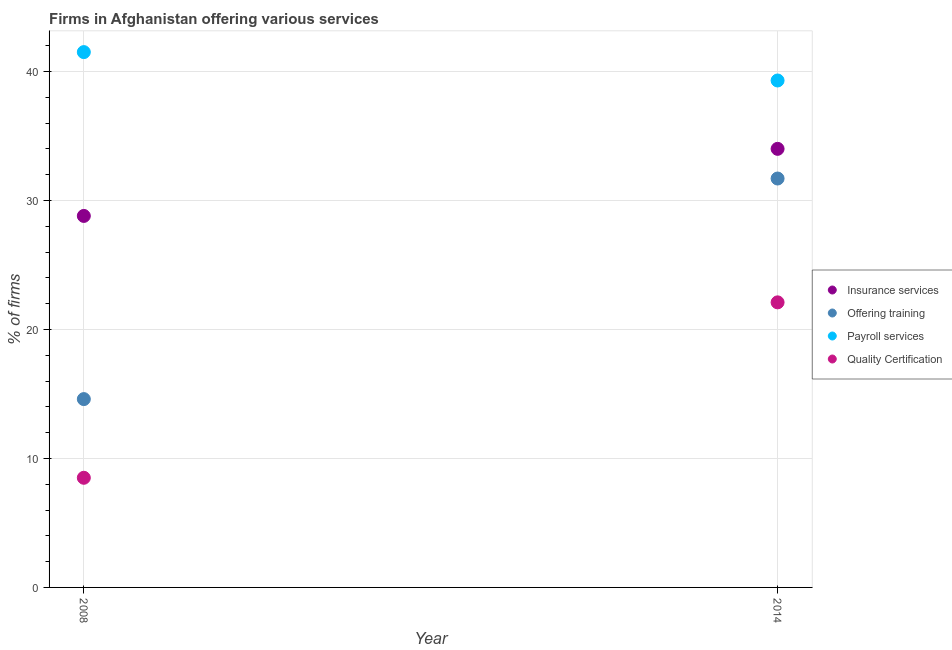How many different coloured dotlines are there?
Your response must be concise. 4. Is the number of dotlines equal to the number of legend labels?
Make the answer very short. Yes. What is the percentage of firms offering payroll services in 2014?
Keep it short and to the point. 39.3. Across all years, what is the minimum percentage of firms offering training?
Provide a succinct answer. 14.6. What is the total percentage of firms offering training in the graph?
Make the answer very short. 46.3. What is the difference between the percentage of firms offering insurance services in 2008 and that in 2014?
Provide a short and direct response. -5.2. What is the difference between the percentage of firms offering training in 2014 and the percentage of firms offering quality certification in 2008?
Provide a succinct answer. 23.2. What is the average percentage of firms offering payroll services per year?
Ensure brevity in your answer.  40.4. In the year 2014, what is the difference between the percentage of firms offering insurance services and percentage of firms offering training?
Your answer should be very brief. 2.3. In how many years, is the percentage of firms offering training greater than 38 %?
Keep it short and to the point. 0. What is the ratio of the percentage of firms offering insurance services in 2008 to that in 2014?
Ensure brevity in your answer.  0.85. Is the percentage of firms offering insurance services in 2008 less than that in 2014?
Keep it short and to the point. Yes. In how many years, is the percentage of firms offering payroll services greater than the average percentage of firms offering payroll services taken over all years?
Offer a very short reply. 1. Is it the case that in every year, the sum of the percentage of firms offering payroll services and percentage of firms offering insurance services is greater than the sum of percentage of firms offering quality certification and percentage of firms offering training?
Offer a terse response. Yes. Is it the case that in every year, the sum of the percentage of firms offering insurance services and percentage of firms offering training is greater than the percentage of firms offering payroll services?
Provide a short and direct response. Yes. Is the percentage of firms offering quality certification strictly greater than the percentage of firms offering payroll services over the years?
Provide a short and direct response. No. How many dotlines are there?
Your answer should be compact. 4. How many years are there in the graph?
Your answer should be compact. 2. What is the difference between two consecutive major ticks on the Y-axis?
Ensure brevity in your answer.  10. Does the graph contain any zero values?
Ensure brevity in your answer.  No. Does the graph contain grids?
Ensure brevity in your answer.  Yes. Where does the legend appear in the graph?
Offer a very short reply. Center right. How many legend labels are there?
Offer a terse response. 4. What is the title of the graph?
Give a very brief answer. Firms in Afghanistan offering various services . What is the label or title of the Y-axis?
Give a very brief answer. % of firms. What is the % of firms of Insurance services in 2008?
Keep it short and to the point. 28.8. What is the % of firms of Payroll services in 2008?
Your response must be concise. 41.5. What is the % of firms of Insurance services in 2014?
Keep it short and to the point. 34. What is the % of firms in Offering training in 2014?
Give a very brief answer. 31.7. What is the % of firms of Payroll services in 2014?
Your answer should be compact. 39.3. What is the % of firms of Quality Certification in 2014?
Give a very brief answer. 22.1. Across all years, what is the maximum % of firms of Offering training?
Give a very brief answer. 31.7. Across all years, what is the maximum % of firms of Payroll services?
Your response must be concise. 41.5. Across all years, what is the maximum % of firms of Quality Certification?
Offer a very short reply. 22.1. Across all years, what is the minimum % of firms of Insurance services?
Provide a short and direct response. 28.8. Across all years, what is the minimum % of firms in Offering training?
Your answer should be compact. 14.6. Across all years, what is the minimum % of firms in Payroll services?
Your answer should be compact. 39.3. What is the total % of firms in Insurance services in the graph?
Offer a terse response. 62.8. What is the total % of firms of Offering training in the graph?
Provide a short and direct response. 46.3. What is the total % of firms in Payroll services in the graph?
Your answer should be compact. 80.8. What is the total % of firms in Quality Certification in the graph?
Keep it short and to the point. 30.6. What is the difference between the % of firms of Insurance services in 2008 and that in 2014?
Your answer should be very brief. -5.2. What is the difference between the % of firms in Offering training in 2008 and that in 2014?
Your answer should be compact. -17.1. What is the difference between the % of firms of Insurance services in 2008 and the % of firms of Offering training in 2014?
Give a very brief answer. -2.9. What is the difference between the % of firms in Insurance services in 2008 and the % of firms in Payroll services in 2014?
Give a very brief answer. -10.5. What is the difference between the % of firms in Offering training in 2008 and the % of firms in Payroll services in 2014?
Your answer should be very brief. -24.7. What is the difference between the % of firms of Offering training in 2008 and the % of firms of Quality Certification in 2014?
Your answer should be compact. -7.5. What is the difference between the % of firms in Payroll services in 2008 and the % of firms in Quality Certification in 2014?
Keep it short and to the point. 19.4. What is the average % of firms in Insurance services per year?
Provide a succinct answer. 31.4. What is the average % of firms of Offering training per year?
Offer a very short reply. 23.15. What is the average % of firms of Payroll services per year?
Provide a short and direct response. 40.4. What is the average % of firms of Quality Certification per year?
Offer a terse response. 15.3. In the year 2008, what is the difference between the % of firms in Insurance services and % of firms in Offering training?
Provide a short and direct response. 14.2. In the year 2008, what is the difference between the % of firms of Insurance services and % of firms of Quality Certification?
Make the answer very short. 20.3. In the year 2008, what is the difference between the % of firms of Offering training and % of firms of Payroll services?
Ensure brevity in your answer.  -26.9. In the year 2014, what is the difference between the % of firms in Insurance services and % of firms in Quality Certification?
Make the answer very short. 11.9. In the year 2014, what is the difference between the % of firms of Offering training and % of firms of Quality Certification?
Your response must be concise. 9.6. In the year 2014, what is the difference between the % of firms in Payroll services and % of firms in Quality Certification?
Keep it short and to the point. 17.2. What is the ratio of the % of firms of Insurance services in 2008 to that in 2014?
Make the answer very short. 0.85. What is the ratio of the % of firms of Offering training in 2008 to that in 2014?
Offer a terse response. 0.46. What is the ratio of the % of firms in Payroll services in 2008 to that in 2014?
Give a very brief answer. 1.06. What is the ratio of the % of firms in Quality Certification in 2008 to that in 2014?
Keep it short and to the point. 0.38. What is the difference between the highest and the second highest % of firms of Insurance services?
Offer a very short reply. 5.2. What is the difference between the highest and the second highest % of firms in Offering training?
Give a very brief answer. 17.1. What is the difference between the highest and the second highest % of firms in Payroll services?
Give a very brief answer. 2.2. What is the difference between the highest and the lowest % of firms of Payroll services?
Provide a short and direct response. 2.2. 